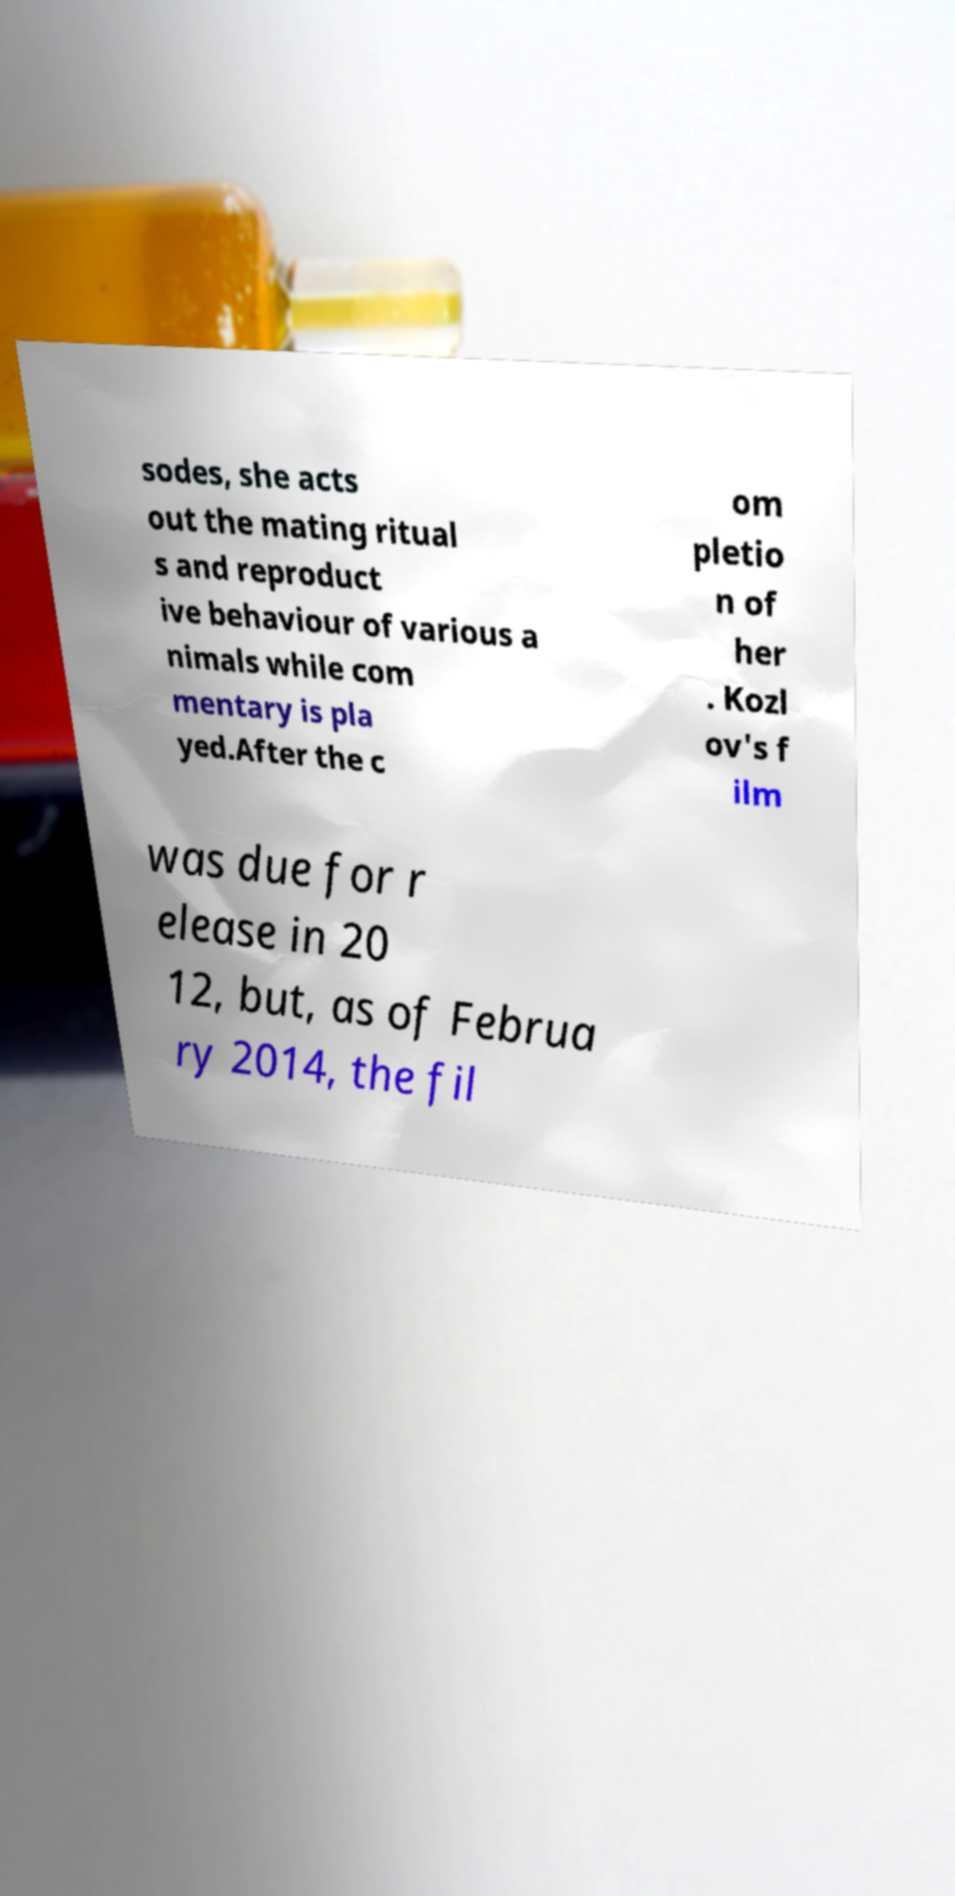For documentation purposes, I need the text within this image transcribed. Could you provide that? sodes, she acts out the mating ritual s and reproduct ive behaviour of various a nimals while com mentary is pla yed.After the c om pletio n of her . Kozl ov's f ilm was due for r elease in 20 12, but, as of Februa ry 2014, the fil 